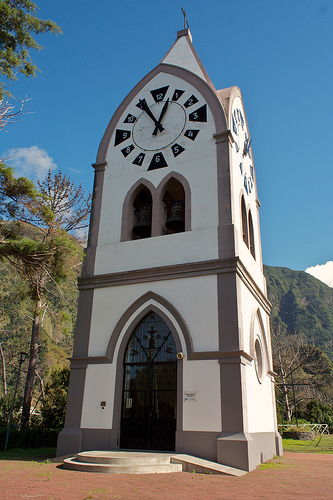Are there any windows that are rectangular? No, there do not appear to be any rectangular windows in the structure. 